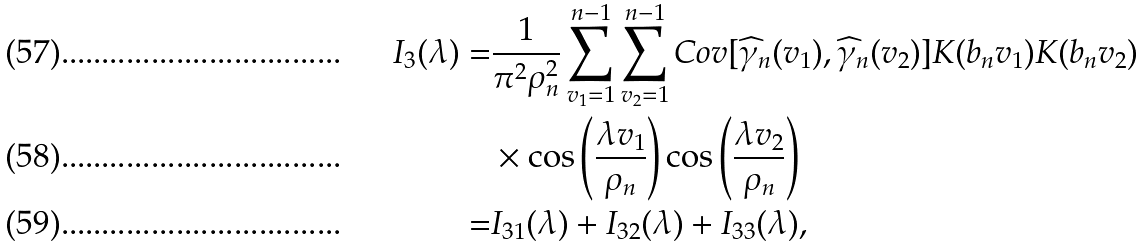Convert formula to latex. <formula><loc_0><loc_0><loc_500><loc_500>I _ { 3 } ( \lambda ) = & \frac { 1 } { \pi ^ { 2 } \rho _ { n } ^ { 2 } } \sum _ { v _ { 1 } = 1 } ^ { n - 1 } \sum _ { v _ { 2 } = 1 } ^ { n - 1 } C o v [ \widehat { \gamma } _ { n } ( v _ { 1 } ) , \widehat { \gamma } _ { n } ( v _ { 2 } ) ] K ( b _ { n } v _ { 1 } ) K ( b _ { n } v _ { 2 } ) \\ & \times \cos \left ( \frac { \lambda v _ { 1 } } { \rho _ { n } } \right ) \cos \left ( \frac { \lambda v _ { 2 } } { \rho _ { n } } \right ) \\ = & I _ { 3 1 } ( \lambda ) + I _ { 3 2 } ( \lambda ) + I _ { 3 3 } ( \lambda ) ,</formula> 